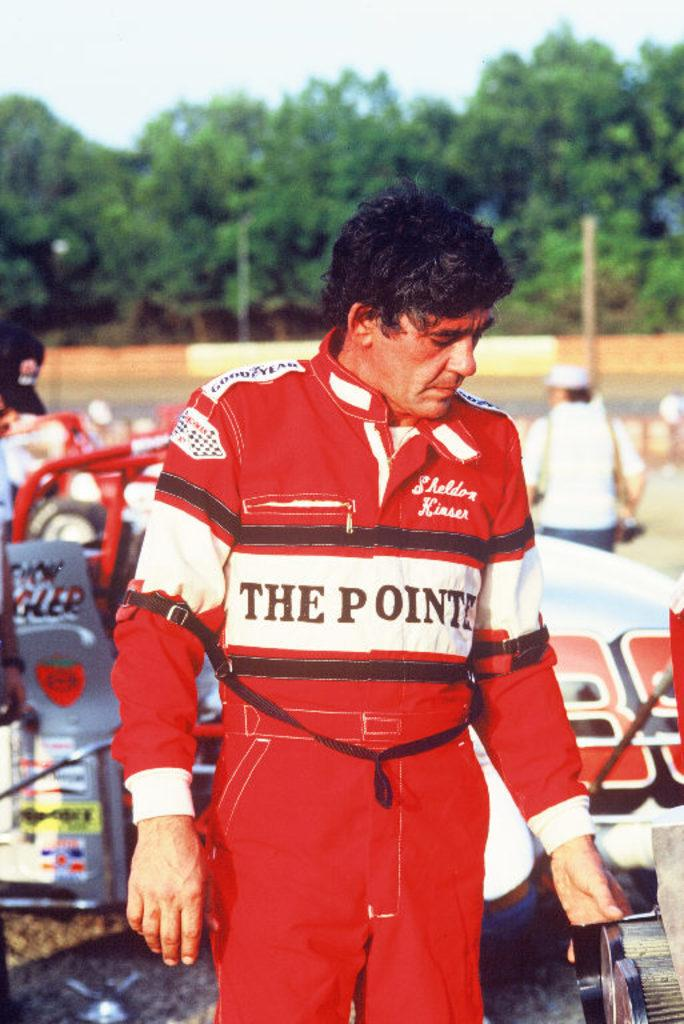<image>
Present a compact description of the photo's key features. A race car driver with a Goodyear advertisement on his shoulder 